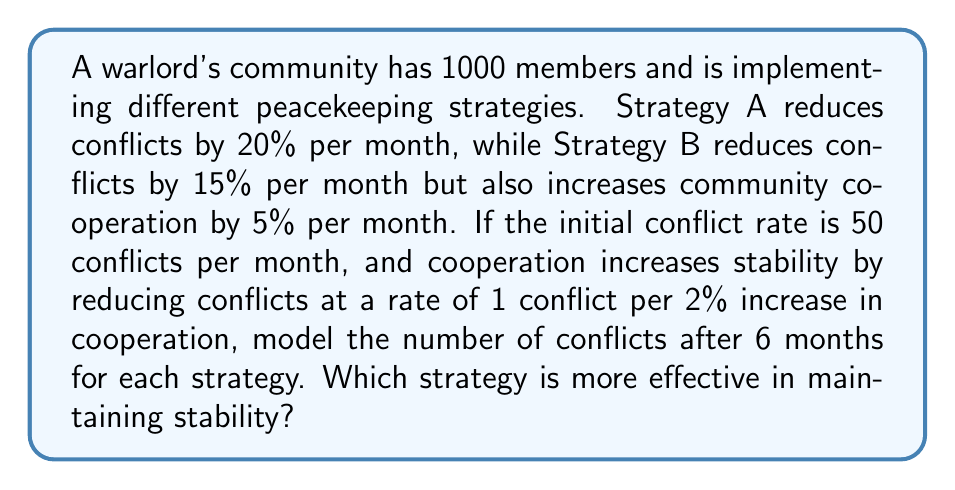Give your solution to this math problem. Let's analyze each strategy separately:

Strategy A:
1) Conflict reduction rate: 20% per month
2) Monthly conflict calculation:
   $$C_n = C_{n-1} \cdot (1 - 0.2)$$
   where $C_n$ is the number of conflicts in month n.
3) After 6 months:
   $$C_6 = 50 \cdot (1 - 0.2)^6 = 50 \cdot 0.8^6 \approx 13.11$$

Strategy B:
1) Conflict reduction rate: 15% per month
2) Cooperation increase: 5% per month
3) Conflict reduction due to cooperation:
   $$\text{Reduction} = \frac{5\% \cdot n}{2\%} = 2.5n$$
   where n is the number of months.
4) Monthly conflict calculation:
   $$C_n = C_{n-1} \cdot (1 - 0.15) - 2.5$$
5) After 6 months:
   $$\begin{align}
   C_1 &= 50 \cdot 0.85 - 2.5 = 40
   C_2 &= 40 \cdot 0.85 - 2.5 = 31.5
   C_3 &= 31.5 \cdot 0.85 - 2.5 = 24.275
   C_4 &= 24.275 \cdot 0.85 - 2.5 = 18.13375
   C_5 &= 18.13375 \cdot 0.85 - 2.5 = 12.91368
   C_6 &= 12.91368 \cdot 0.85 - 2.5 = 8.47663
   \end{align}$$

Strategy B results in fewer conflicts after 6 months (approximately 8.48 compared to 13.11 for Strategy A), making it more effective in maintaining stability.
Answer: Strategy B: 8.48 conflicts 